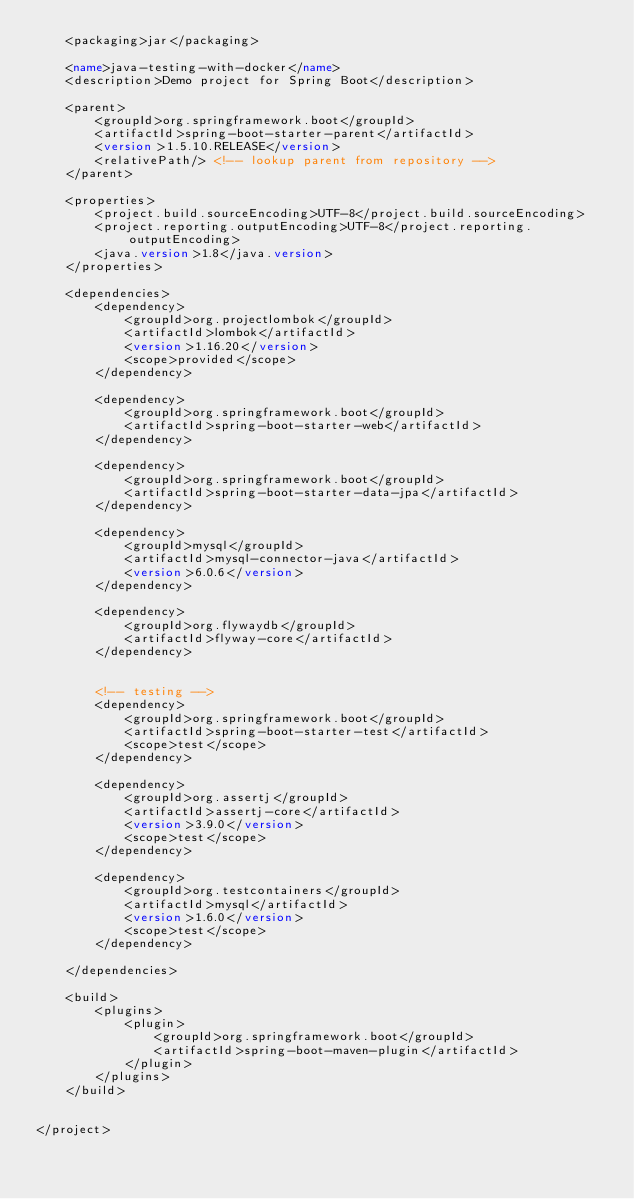Convert code to text. <code><loc_0><loc_0><loc_500><loc_500><_XML_>	<packaging>jar</packaging>

	<name>java-testing-with-docker</name>
	<description>Demo project for Spring Boot</description>

	<parent>
		<groupId>org.springframework.boot</groupId>
		<artifactId>spring-boot-starter-parent</artifactId>
		<version>1.5.10.RELEASE</version>
		<relativePath/> <!-- lookup parent from repository -->
	</parent>

	<properties>
		<project.build.sourceEncoding>UTF-8</project.build.sourceEncoding>
		<project.reporting.outputEncoding>UTF-8</project.reporting.outputEncoding>
		<java.version>1.8</java.version>
	</properties>

	<dependencies>
		<dependency>
			<groupId>org.projectlombok</groupId>
			<artifactId>lombok</artifactId>
			<version>1.16.20</version>
			<scope>provided</scope>
		</dependency>

		<dependency>
			<groupId>org.springframework.boot</groupId>
			<artifactId>spring-boot-starter-web</artifactId>
		</dependency>

		<dependency>
			<groupId>org.springframework.boot</groupId>
			<artifactId>spring-boot-starter-data-jpa</artifactId>
		</dependency>

		<dependency>
			<groupId>mysql</groupId>
			<artifactId>mysql-connector-java</artifactId>
			<version>6.0.6</version>
		</dependency>

		<dependency>
			<groupId>org.flywaydb</groupId>
			<artifactId>flyway-core</artifactId>
		</dependency>


		<!-- testing -->
		<dependency>
			<groupId>org.springframework.boot</groupId>
			<artifactId>spring-boot-starter-test</artifactId>
			<scope>test</scope>
		</dependency>

		<dependency>
			<groupId>org.assertj</groupId>
			<artifactId>assertj-core</artifactId>
			<version>3.9.0</version>
			<scope>test</scope>
		</dependency>

		<dependency>
			<groupId>org.testcontainers</groupId>
			<artifactId>mysql</artifactId>
			<version>1.6.0</version>
			<scope>test</scope>
		</dependency>

	</dependencies>

	<build>
		<plugins>
			<plugin>
				<groupId>org.springframework.boot</groupId>
				<artifactId>spring-boot-maven-plugin</artifactId>
			</plugin>
		</plugins>
	</build>


</project>
</code> 